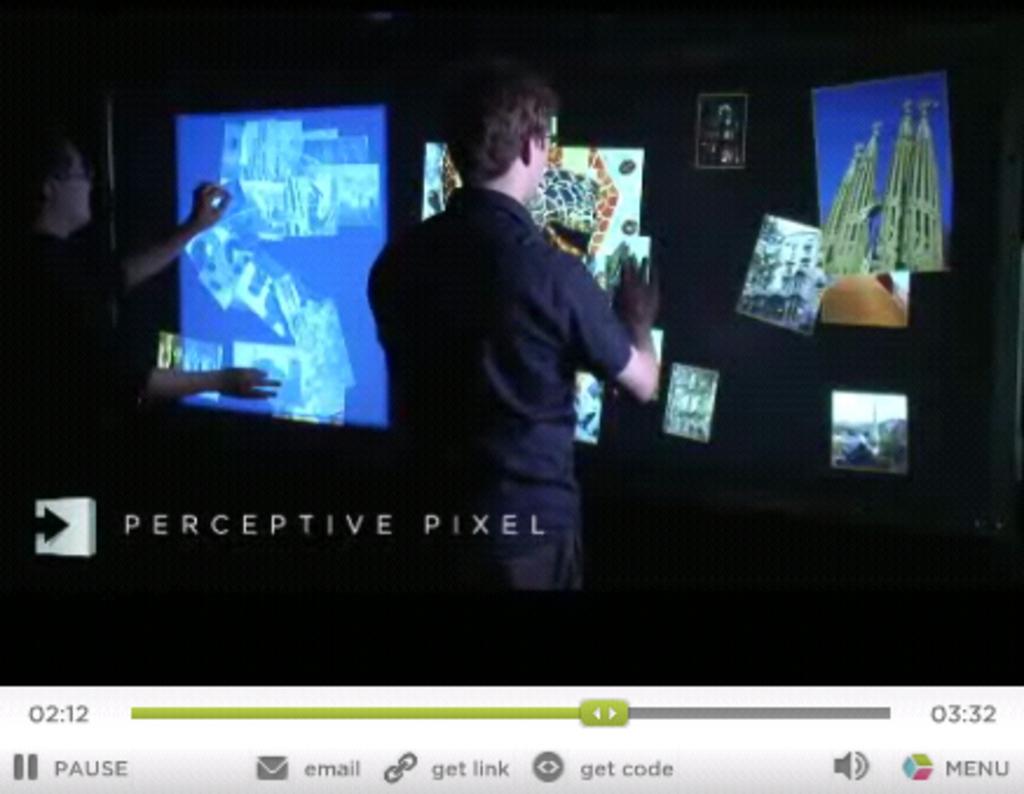How much time is shown on the left?
Your answer should be very brief. 2:12. What kind of pixel is mentioned?
Offer a very short reply. Perceptive. 